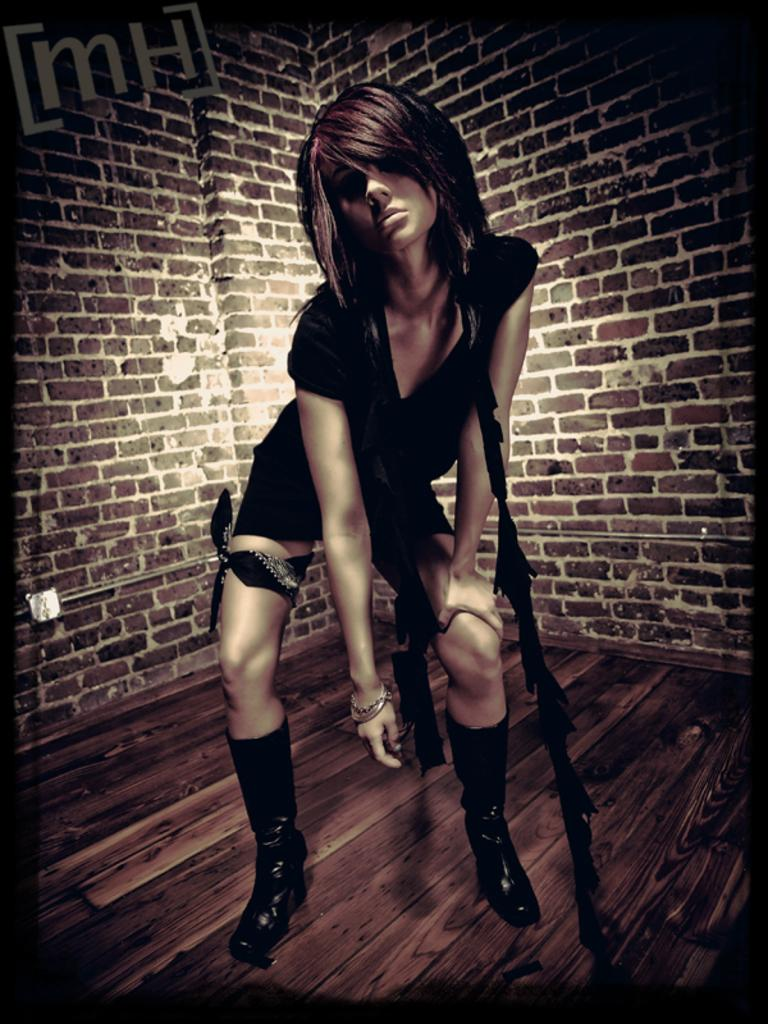Who is the main subject in the foreground of the image? There is a girl in the foreground of the image. What can be seen in the background of the image? There is a wall and text visible in the background of the image. How many spiders are crawling on the girl's head in the image? There are no spiders visible in the image, and the girl's head is not mentioned in the provided facts. 